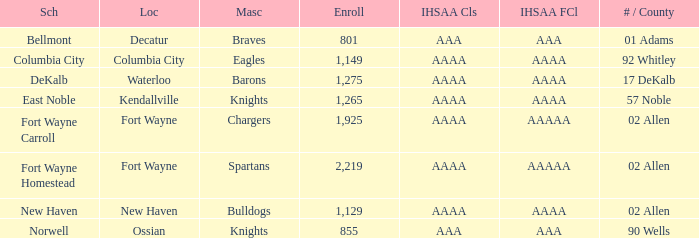What school has a mascot of the spartans with an AAAA IHSAA class and more than 1,275 enrolled? Fort Wayne Homestead. 